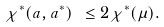<formula> <loc_0><loc_0><loc_500><loc_500>\chi ^ { * } ( a , a ^ { * } ) \ \leq 2 \chi ^ { * } ( \mu ) .</formula> 